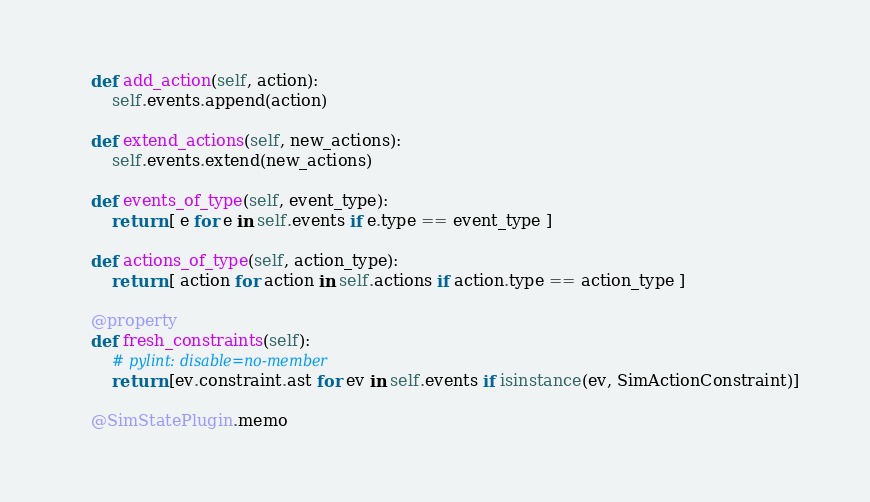Convert code to text. <code><loc_0><loc_0><loc_500><loc_500><_Python_>    def add_action(self, action):
        self.events.append(action)

    def extend_actions(self, new_actions):
        self.events.extend(new_actions)

    def events_of_type(self, event_type):
        return [ e for e in self.events if e.type == event_type ]

    def actions_of_type(self, action_type):
        return [ action for action in self.actions if action.type == action_type ]

    @property
    def fresh_constraints(self):
        # pylint: disable=no-member
        return [ev.constraint.ast for ev in self.events if isinstance(ev, SimActionConstraint)]

    @SimStatePlugin.memo</code> 